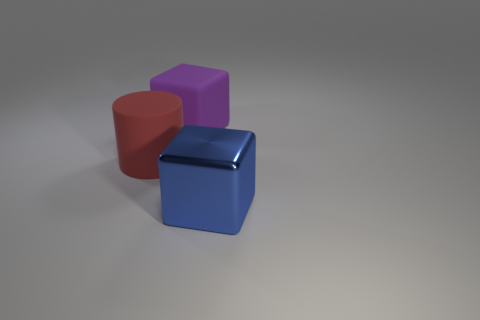The other big object that is the same shape as the big purple rubber object is what color?
Provide a short and direct response. Blue. Is the number of large blue metallic things that are in front of the red matte cylinder greater than the number of small red rubber blocks?
Your answer should be very brief. Yes. There is a matte object in front of the purple matte cube; what is its color?
Provide a short and direct response. Red. Is the red object the same size as the purple rubber cube?
Provide a succinct answer. Yes. The blue cube is what size?
Provide a succinct answer. Large. Is the number of tiny red rubber balls greater than the number of red cylinders?
Offer a terse response. No. What color is the block behind the blue metal object that is right of the big thing to the left of the large purple block?
Your answer should be very brief. Purple. There is a matte object right of the large red object; does it have the same shape as the red rubber object?
Give a very brief answer. No. There is a metal cube that is the same size as the red rubber cylinder; what color is it?
Offer a terse response. Blue. How many small purple metallic spheres are there?
Offer a terse response. 0. 